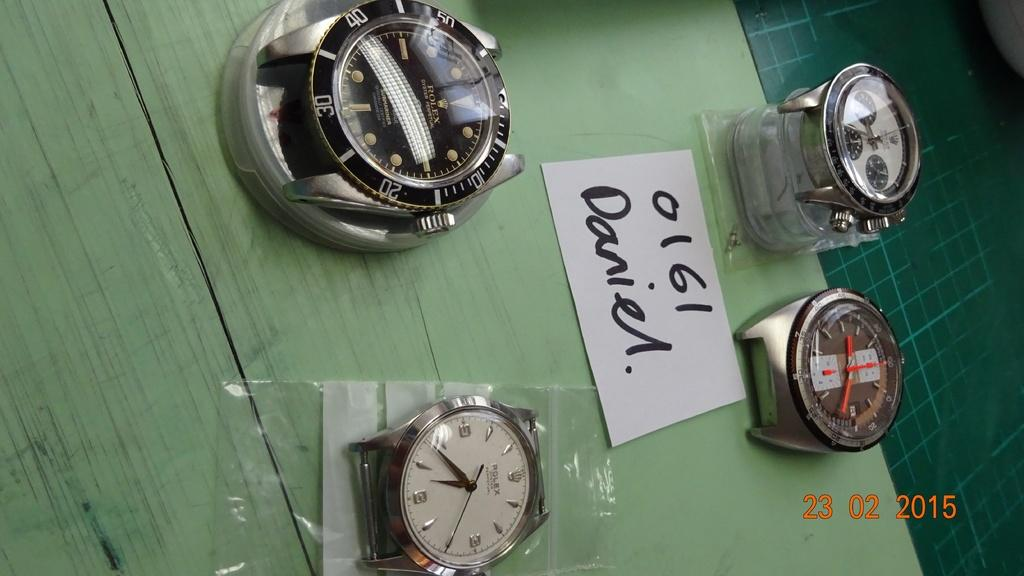<image>
Present a compact description of the photo's key features. A group of strapless watch faces with a piece of paper that says 0161 Daniel on it. 